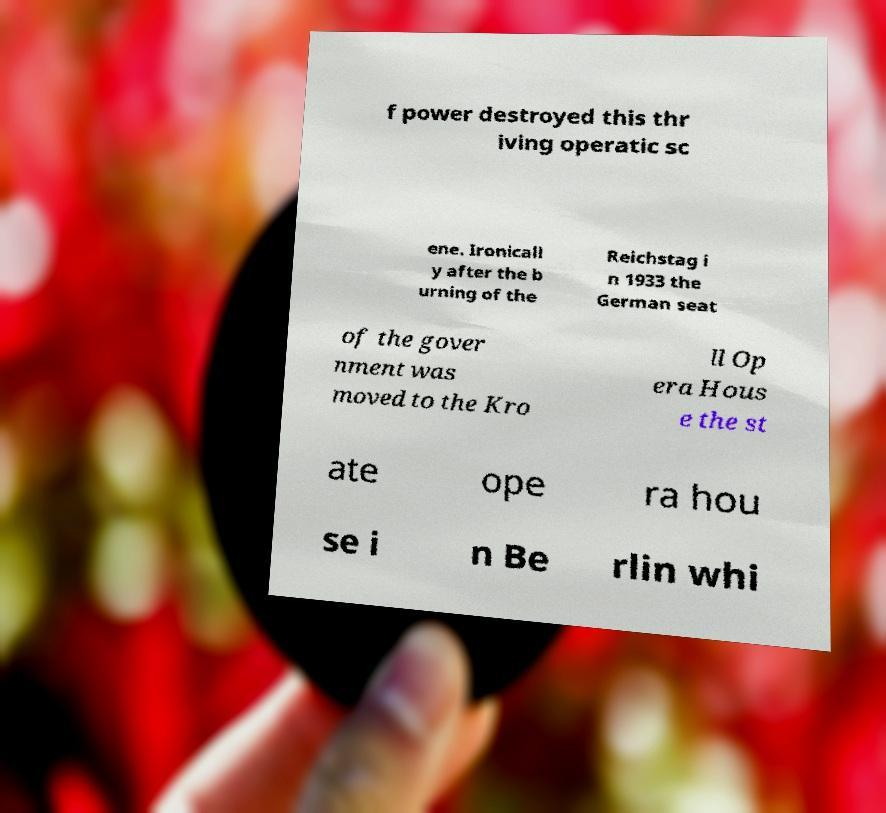Could you extract and type out the text from this image? f power destroyed this thr iving operatic sc ene. Ironicall y after the b urning of the Reichstag i n 1933 the German seat of the gover nment was moved to the Kro ll Op era Hous e the st ate ope ra hou se i n Be rlin whi 